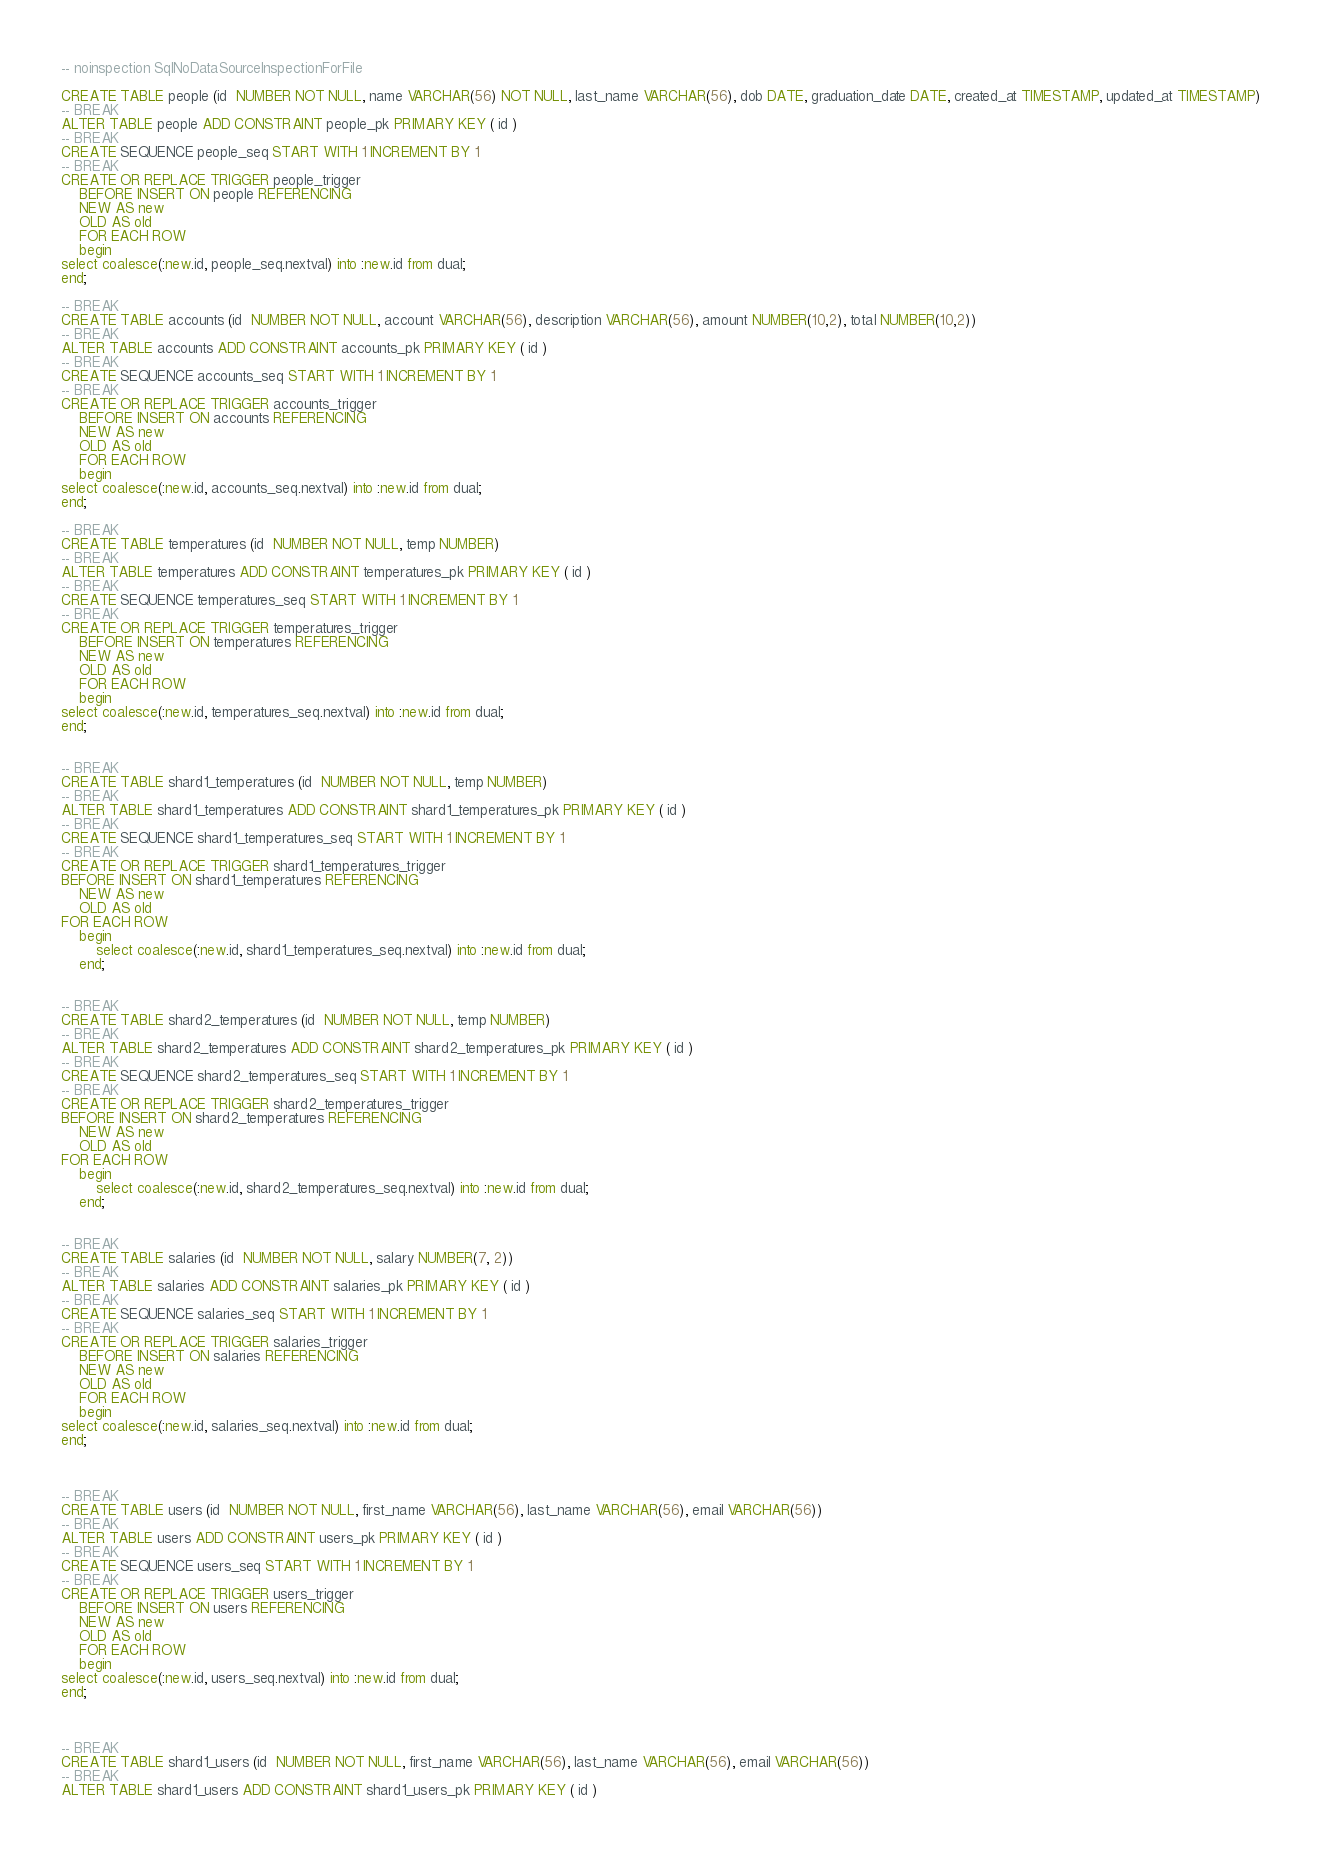<code> <loc_0><loc_0><loc_500><loc_500><_SQL_>-- noinspection SqlNoDataSourceInspectionForFile

CREATE TABLE people (id  NUMBER NOT NULL, name VARCHAR(56) NOT NULL, last_name VARCHAR(56), dob DATE, graduation_date DATE, created_at TIMESTAMP, updated_at TIMESTAMP)
-- BREAK
ALTER TABLE people ADD CONSTRAINT people_pk PRIMARY KEY ( id )
-- BREAK
CREATE SEQUENCE people_seq START WITH 1 INCREMENT BY 1
-- BREAK
CREATE OR REPLACE TRIGGER people_trigger
    BEFORE INSERT ON people REFERENCING
    NEW AS new
    OLD AS old
    FOR EACH ROW
    begin
select coalesce(:new.id, people_seq.nextval) into :new.id from dual;
end;

-- BREAK
CREATE TABLE accounts (id  NUMBER NOT NULL, account VARCHAR(56), description VARCHAR(56), amount NUMBER(10,2), total NUMBER(10,2))
-- BREAK
ALTER TABLE accounts ADD CONSTRAINT accounts_pk PRIMARY KEY ( id )
-- BREAK
CREATE SEQUENCE accounts_seq START WITH 1 INCREMENT BY 1
-- BREAK
CREATE OR REPLACE TRIGGER accounts_trigger
    BEFORE INSERT ON accounts REFERENCING
    NEW AS new
    OLD AS old
    FOR EACH ROW
    begin
select coalesce(:new.id, accounts_seq.nextval) into :new.id from dual;
end;

-- BREAK
CREATE TABLE temperatures (id  NUMBER NOT NULL, temp NUMBER)
-- BREAK
ALTER TABLE temperatures ADD CONSTRAINT temperatures_pk PRIMARY KEY ( id )
-- BREAK
CREATE SEQUENCE temperatures_seq START WITH 1 INCREMENT BY 1
-- BREAK
CREATE OR REPLACE TRIGGER temperatures_trigger
    BEFORE INSERT ON temperatures REFERENCING
    NEW AS new
    OLD AS old
    FOR EACH ROW
    begin
select coalesce(:new.id, temperatures_seq.nextval) into :new.id from dual;
end;


-- BREAK
CREATE TABLE shard1_temperatures (id  NUMBER NOT NULL, temp NUMBER)
-- BREAK
ALTER TABLE shard1_temperatures ADD CONSTRAINT shard1_temperatures_pk PRIMARY KEY ( id )
-- BREAK
CREATE SEQUENCE shard1_temperatures_seq START WITH 1 INCREMENT BY 1
-- BREAK
CREATE OR REPLACE TRIGGER shard1_temperatures_trigger
BEFORE INSERT ON shard1_temperatures REFERENCING
    NEW AS new
    OLD AS old
FOR EACH ROW
    begin
        select coalesce(:new.id, shard1_temperatures_seq.nextval) into :new.id from dual;
    end;


-- BREAK
CREATE TABLE shard2_temperatures (id  NUMBER NOT NULL, temp NUMBER)
-- BREAK
ALTER TABLE shard2_temperatures ADD CONSTRAINT shard2_temperatures_pk PRIMARY KEY ( id )
-- BREAK
CREATE SEQUENCE shard2_temperatures_seq START WITH 1 INCREMENT BY 1
-- BREAK
CREATE OR REPLACE TRIGGER shard2_temperatures_trigger
BEFORE INSERT ON shard2_temperatures REFERENCING
    NEW AS new
    OLD AS old
FOR EACH ROW
    begin
        select coalesce(:new.id, shard2_temperatures_seq.nextval) into :new.id from dual;
    end;


-- BREAK
CREATE TABLE salaries (id  NUMBER NOT NULL, salary NUMBER(7, 2))
-- BREAK
ALTER TABLE salaries ADD CONSTRAINT salaries_pk PRIMARY KEY ( id )
-- BREAK
CREATE SEQUENCE salaries_seq START WITH 1 INCREMENT BY 1
-- BREAK
CREATE OR REPLACE TRIGGER salaries_trigger
    BEFORE INSERT ON salaries REFERENCING
    NEW AS new
    OLD AS old
    FOR EACH ROW
    begin
select coalesce(:new.id, salaries_seq.nextval) into :new.id from dual;
end;



-- BREAK
CREATE TABLE users (id  NUMBER NOT NULL, first_name VARCHAR(56), last_name VARCHAR(56), email VARCHAR(56))
-- BREAK
ALTER TABLE users ADD CONSTRAINT users_pk PRIMARY KEY ( id )
-- BREAK
CREATE SEQUENCE users_seq START WITH 1 INCREMENT BY 1
-- BREAK
CREATE OR REPLACE TRIGGER users_trigger
    BEFORE INSERT ON users REFERENCING
    NEW AS new
    OLD AS old
    FOR EACH ROW
    begin
select coalesce(:new.id, users_seq.nextval) into :new.id from dual;
end;



-- BREAK
CREATE TABLE shard1_users (id  NUMBER NOT NULL, first_name VARCHAR(56), last_name VARCHAR(56), email VARCHAR(56))
-- BREAK
ALTER TABLE shard1_users ADD CONSTRAINT shard1_users_pk PRIMARY KEY ( id )</code> 